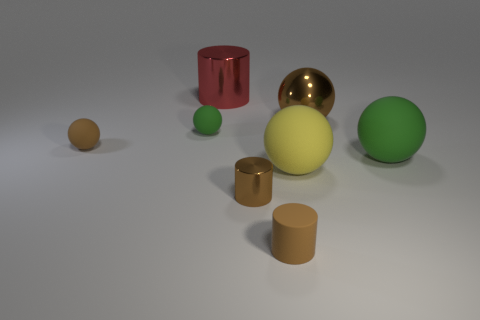What number of tiny brown objects are made of the same material as the yellow thing?
Ensure brevity in your answer.  2. There is a tiny brown rubber sphere; are there any cylinders to the left of it?
Ensure brevity in your answer.  No. What is the color of the other cylinder that is the same size as the brown shiny cylinder?
Offer a very short reply. Brown. What number of objects are either green matte things that are right of the small brown shiny cylinder or brown rubber objects?
Your answer should be very brief. 3. There is a matte sphere that is to the right of the brown rubber ball and left of the big red metal cylinder; what size is it?
Provide a short and direct response. Small. The matte cylinder that is the same color as the large metallic sphere is what size?
Provide a short and direct response. Small. How many other objects are there of the same size as the brown shiny cylinder?
Offer a terse response. 3. The matte thing behind the object on the left side of the green thing left of the tiny brown matte cylinder is what color?
Keep it short and to the point. Green. What shape is the object that is both in front of the big yellow matte thing and behind the matte cylinder?
Your answer should be very brief. Cylinder. How many other things are the same shape as the yellow object?
Your answer should be compact. 4. 